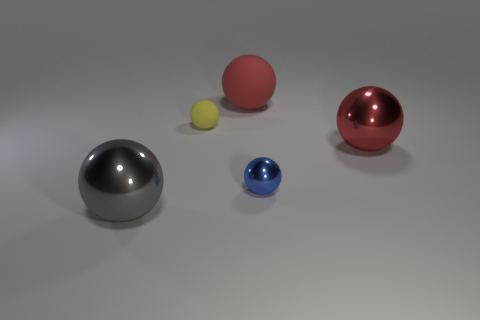There is a large ball that is behind the big shiny object right of the big gray sphere; what color is it?
Your answer should be very brief. Red. Are there any shiny spheres that have the same color as the large rubber object?
Offer a very short reply. Yes. The rubber sphere that is the same size as the blue metallic thing is what color?
Your answer should be compact. Yellow. Does the large red ball behind the yellow matte thing have the same material as the small yellow ball?
Make the answer very short. Yes. Is there a tiny yellow object that is behind the yellow object behind the large metal object to the right of the big red rubber object?
Offer a very short reply. No. There is a small thing right of the small yellow thing; is it the same shape as the gray metallic thing?
Your answer should be compact. Yes. There is a large red object that is left of the large shiny thing that is to the right of the large gray metal ball; what is its shape?
Your answer should be compact. Sphere. There is a red object that is on the left side of the large shiny sphere that is to the right of the large ball that is behind the tiny yellow rubber object; what size is it?
Your answer should be very brief. Large. There is a small metallic object that is the same shape as the large gray object; what is its color?
Offer a terse response. Blue. Do the red metallic object and the gray object have the same size?
Provide a short and direct response. Yes. 